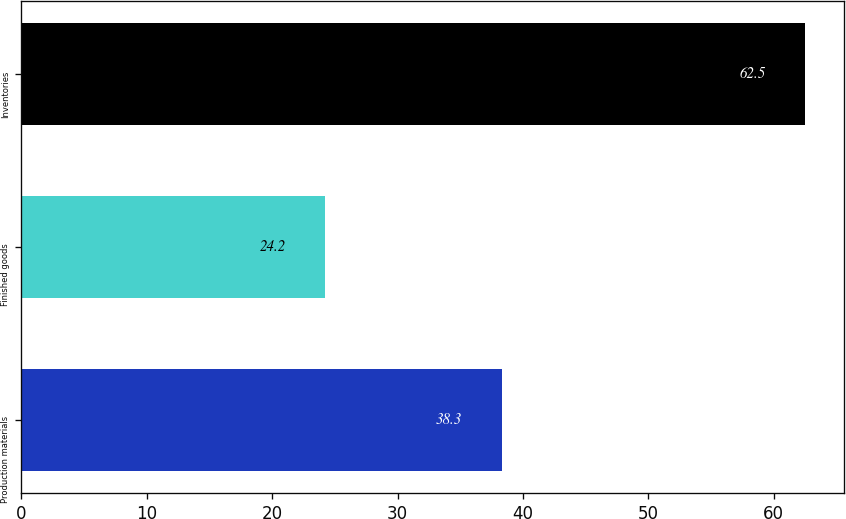Convert chart. <chart><loc_0><loc_0><loc_500><loc_500><bar_chart><fcel>Production materials<fcel>Finished goods<fcel>Inventories<nl><fcel>38.3<fcel>24.2<fcel>62.5<nl></chart> 